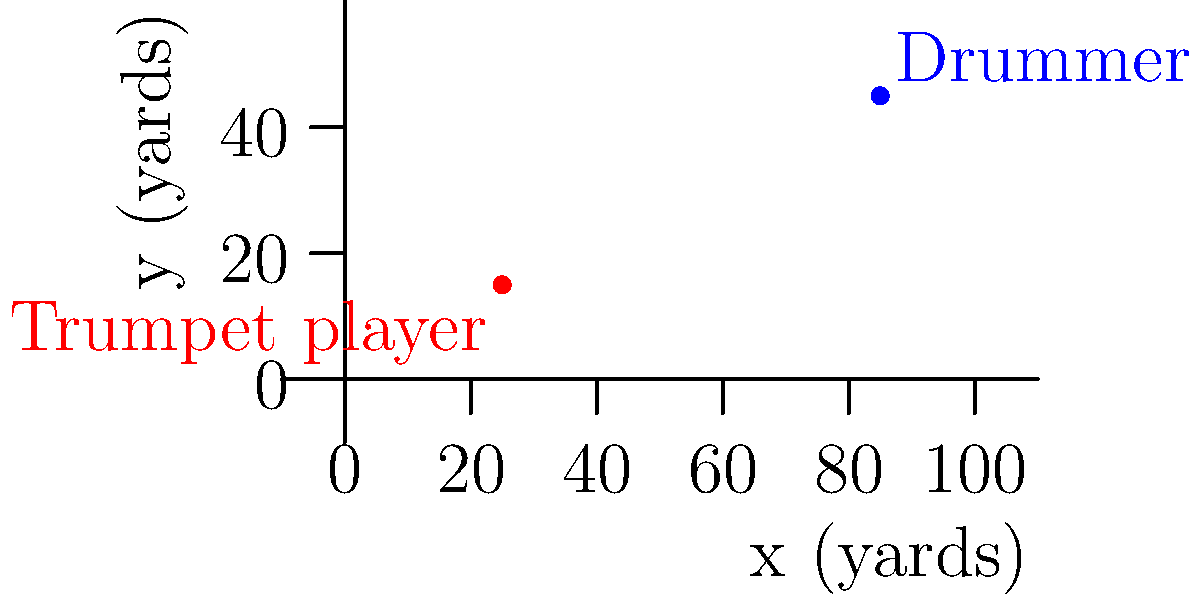During a halftime show, a trumpet player and a drummer are positioned on the football field. The trumpet player is at coordinates (25, 15) and the drummer is at (85, 45), where coordinates are measured in yards from the southwest corner of the field. Calculate the straight-line distance between these two band members. To find the distance between two points, we can use the distance formula:

$$d = \sqrt{(x_2-x_1)^2 + (y_2-y_1)^2}$$

Where $(x_1,y_1)$ is the position of the trumpet player and $(x_2,y_2)$ is the position of the drummer.

1) First, let's identify our coordinates:
   Trumpet player: $(x_1,y_1) = (25,15)$
   Drummer: $(x_2,y_2) = (85,45)$

2) Now, let's substitute these into the distance formula:
   $$d = \sqrt{(85-25)^2 + (45-15)^2}$$

3) Simplify inside the parentheses:
   $$d = \sqrt{60^2 + 30^2}$$

4) Calculate the squares:
   $$d = \sqrt{3600 + 900}$$

5) Add under the square root:
   $$d = \sqrt{4500}$$

6) Simplify the square root:
   $$d = 30\sqrt{5} \approx 67.08$$

Therefore, the distance between the trumpet player and the drummer is $30\sqrt{5}$ yards, or approximately 67.08 yards.
Answer: $30\sqrt{5}$ yards 